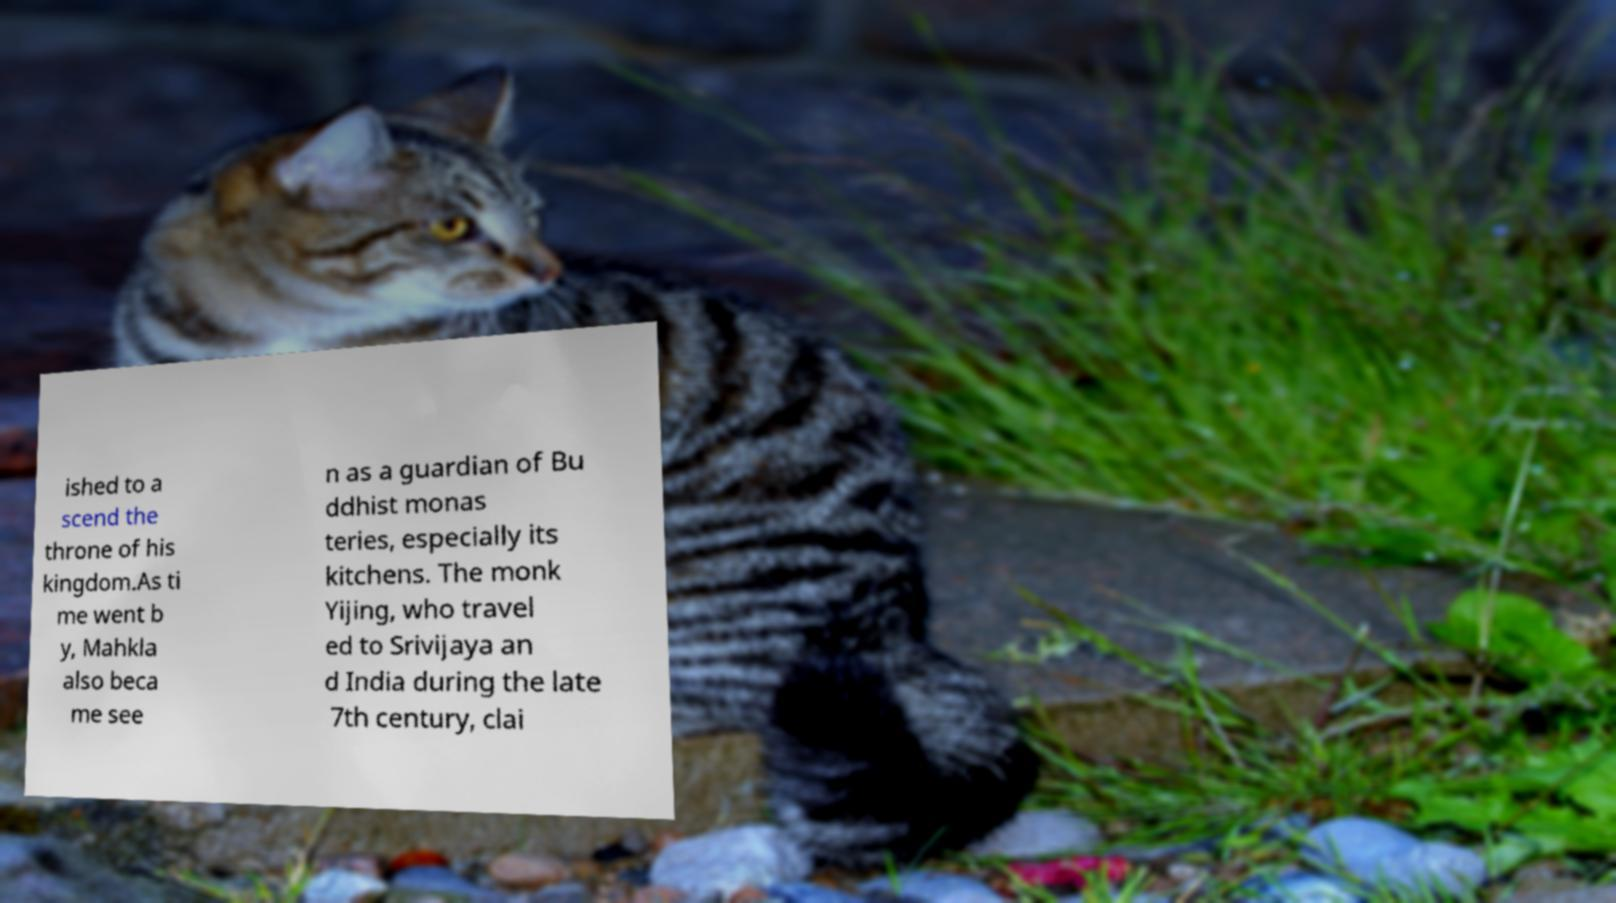For documentation purposes, I need the text within this image transcribed. Could you provide that? ished to a scend the throne of his kingdom.As ti me went b y, Mahkla also beca me see n as a guardian of Bu ddhist monas teries, especially its kitchens. The monk Yijing, who travel ed to Srivijaya an d India during the late 7th century, clai 